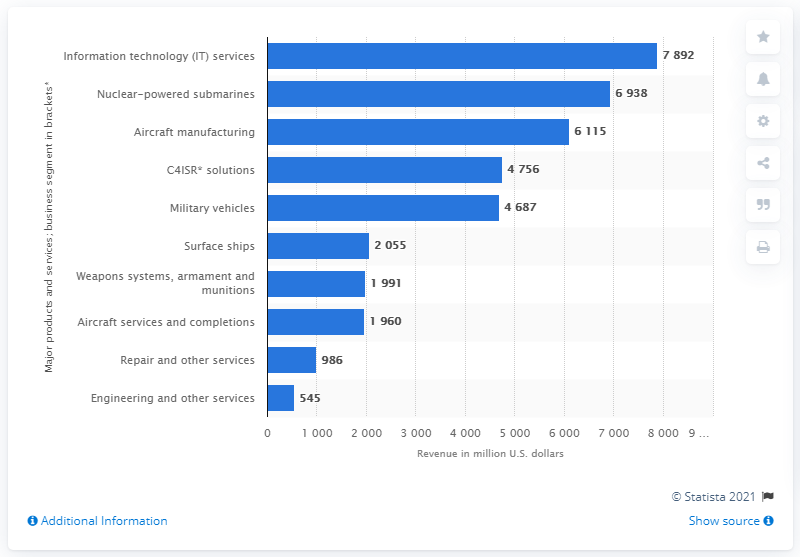Highlight a few significant elements in this photo. In 2020, the revenue generated from military vehicles was 4,687. 